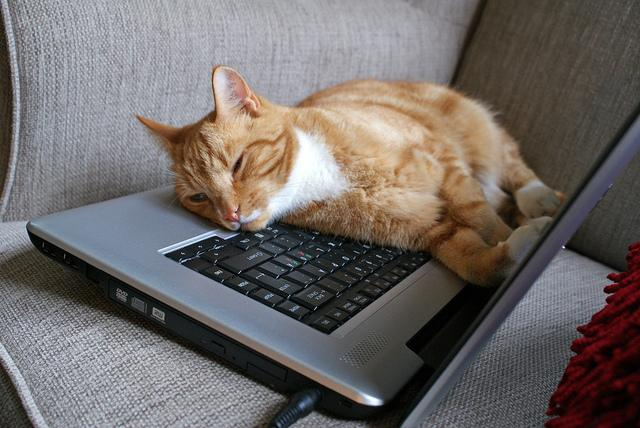Why is the cat likely sleeping on the laptop? Please explain your reasoning. heat. The laptop is warm for him to sleep on. 